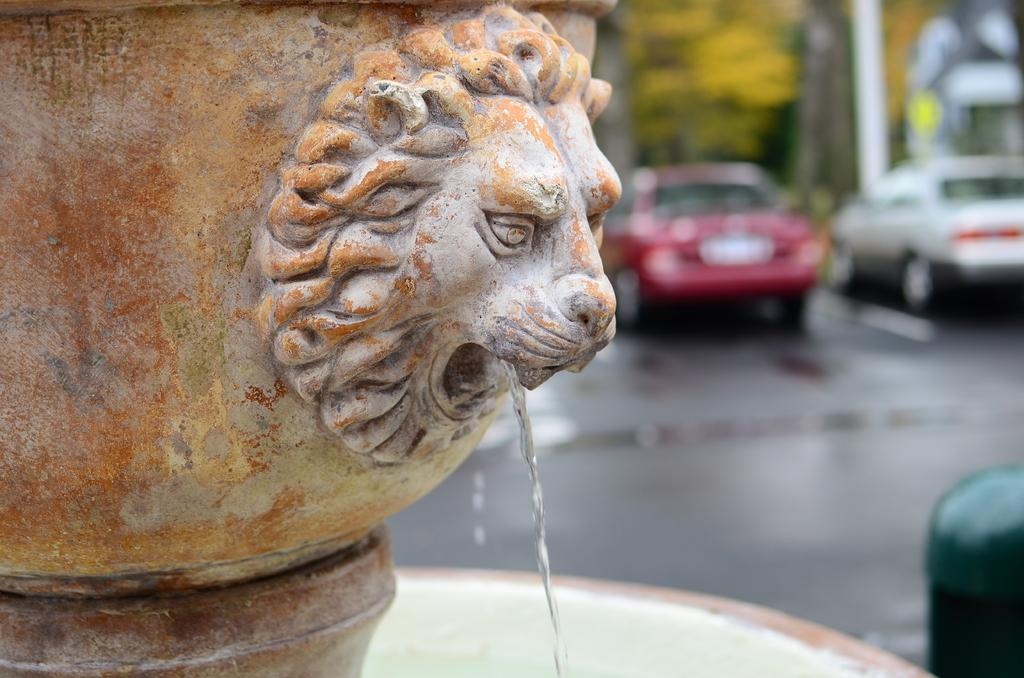What is the main feature at the front of the image? There is a fountain at the front of the image. What can be seen in the middle of the image? There are cars on the road in the center of the image. What type of vegetation is at the back side of the image? There are trees at the back side of the image. What color is the hair on the tree in the image? There is no hair present in the image, as it features a fountain, cars, and trees. What type of sheet is covering the fountain in the image? There is no sheet present in the image; the fountain is not covered. 